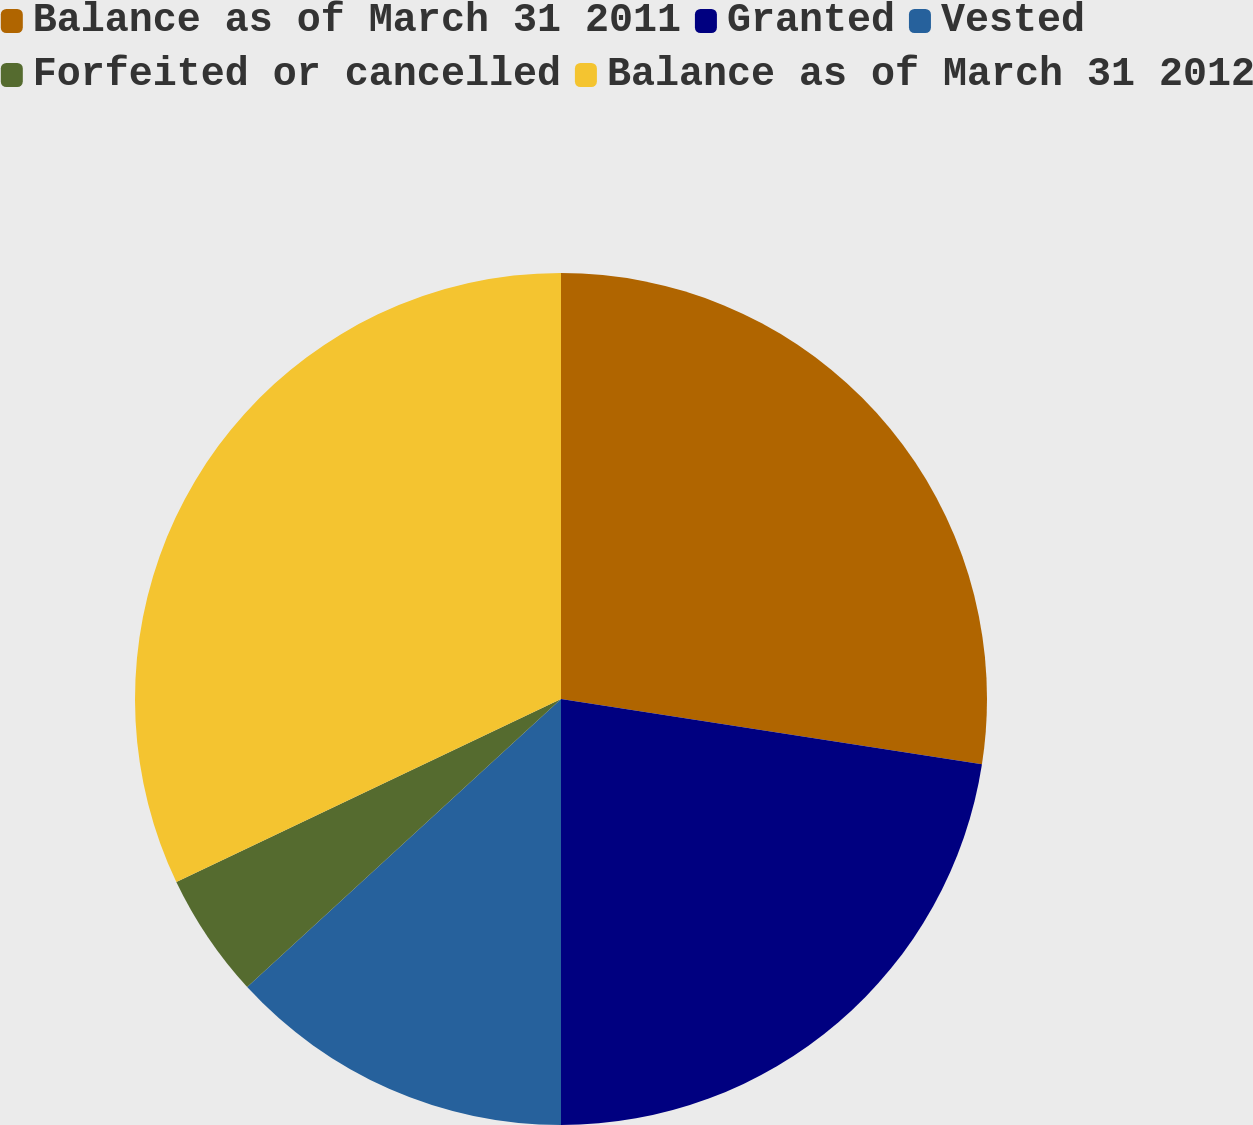Convert chart. <chart><loc_0><loc_0><loc_500><loc_500><pie_chart><fcel>Balance as of March 31 2011<fcel>Granted<fcel>Vested<fcel>Forfeited or cancelled<fcel>Balance as of March 31 2012<nl><fcel>27.45%<fcel>22.55%<fcel>13.18%<fcel>4.75%<fcel>32.07%<nl></chart> 